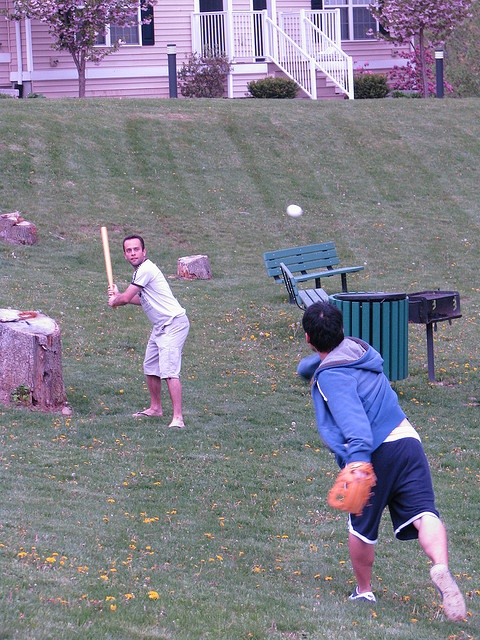Describe the objects in this image and their specific colors. I can see people in violet, lavender, navy, blue, and black tones, bench in violet and gray tones, baseball glove in violet, lightpink, salmon, brown, and pink tones, bench in violet, lavender, gray, and navy tones, and baseball bat in violet, white, lightpink, darkgray, and gray tones in this image. 